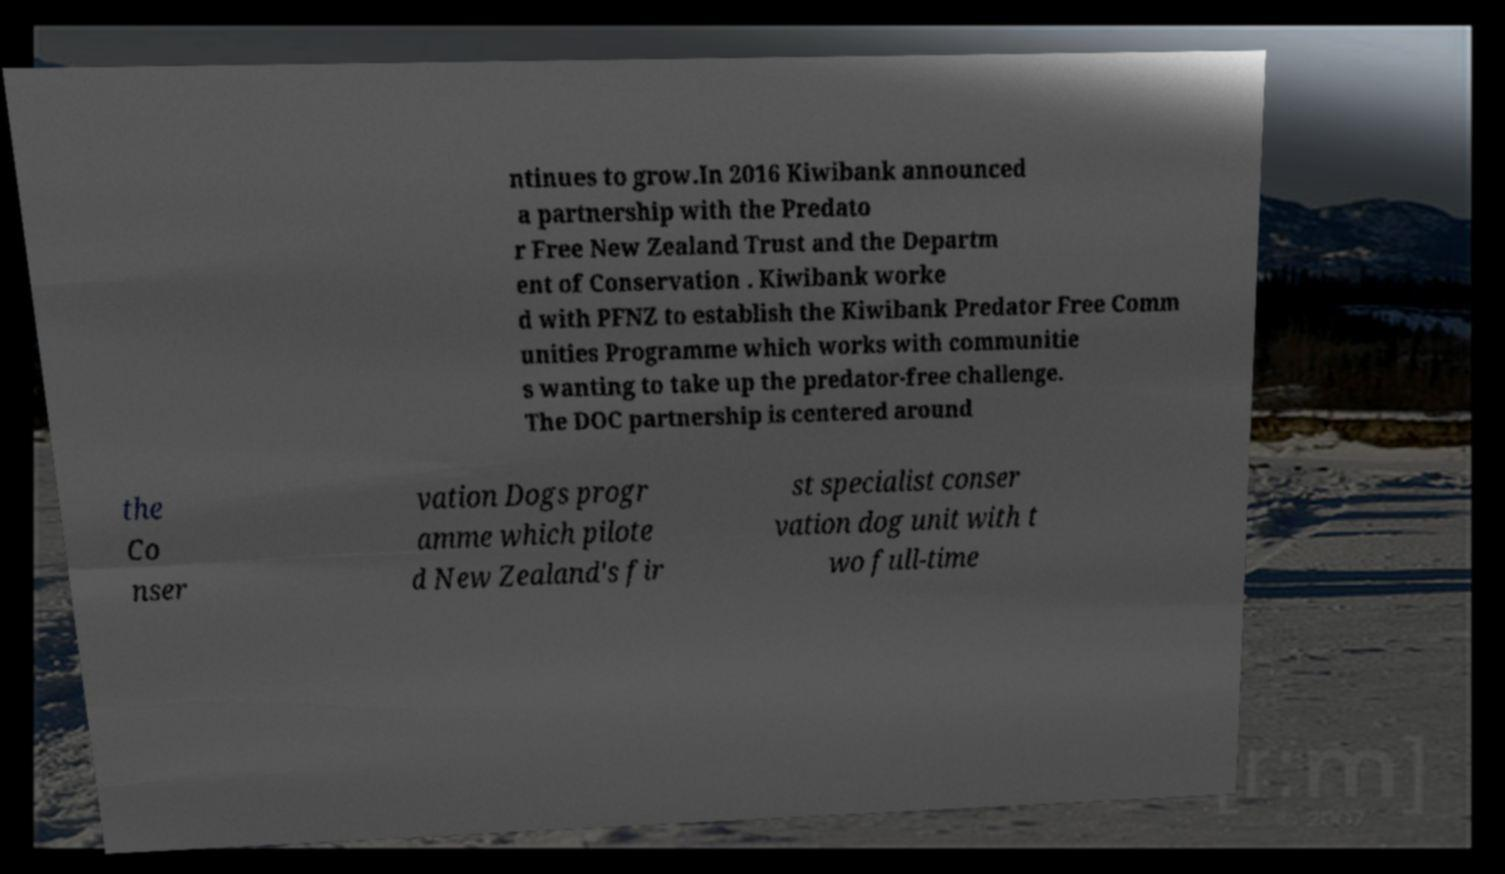For documentation purposes, I need the text within this image transcribed. Could you provide that? ntinues to grow.In 2016 Kiwibank announced a partnership with the Predato r Free New Zealand Trust and the Departm ent of Conservation . Kiwibank worke d with PFNZ to establish the Kiwibank Predator Free Comm unities Programme which works with communitie s wanting to take up the predator-free challenge. The DOC partnership is centered around the Co nser vation Dogs progr amme which pilote d New Zealand's fir st specialist conser vation dog unit with t wo full-time 